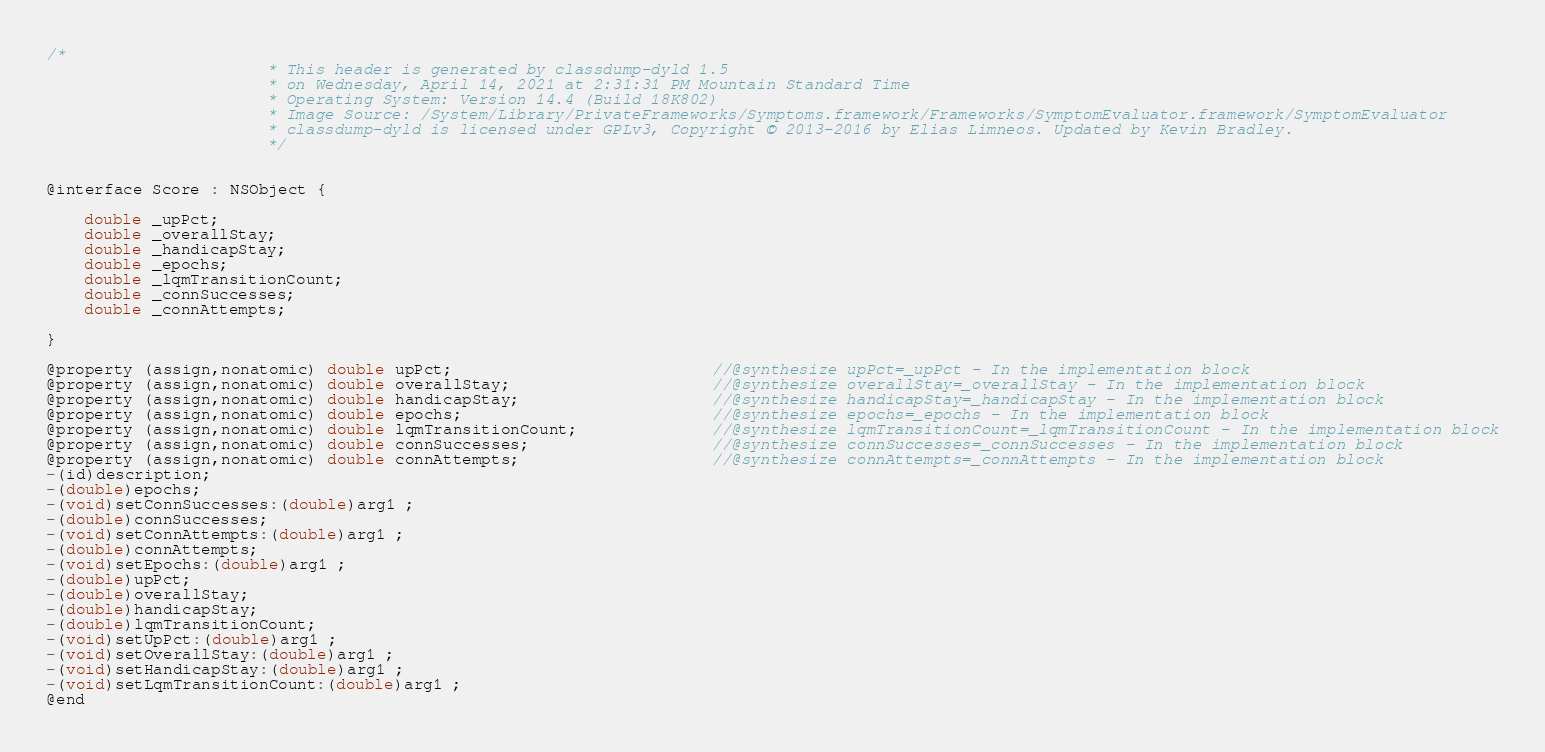Convert code to text. <code><loc_0><loc_0><loc_500><loc_500><_C_>/*
                       * This header is generated by classdump-dyld 1.5
                       * on Wednesday, April 14, 2021 at 2:31:31 PM Mountain Standard Time
                       * Operating System: Version 14.4 (Build 18K802)
                       * Image Source: /System/Library/PrivateFrameworks/Symptoms.framework/Frameworks/SymptomEvaluator.framework/SymptomEvaluator
                       * classdump-dyld is licensed under GPLv3, Copyright © 2013-2016 by Elias Limneos. Updated by Kevin Bradley.
                       */


@interface Score : NSObject {

	double _upPct;
	double _overallStay;
	double _handicapStay;
	double _epochs;
	double _lqmTransitionCount;
	double _connSuccesses;
	double _connAttempts;

}

@property (assign,nonatomic) double upPct;                           //@synthesize upPct=_upPct - In the implementation block
@property (assign,nonatomic) double overallStay;                     //@synthesize overallStay=_overallStay - In the implementation block
@property (assign,nonatomic) double handicapStay;                    //@synthesize handicapStay=_handicapStay - In the implementation block
@property (assign,nonatomic) double epochs;                          //@synthesize epochs=_epochs - In the implementation block
@property (assign,nonatomic) double lqmTransitionCount;              //@synthesize lqmTransitionCount=_lqmTransitionCount - In the implementation block
@property (assign,nonatomic) double connSuccesses;                   //@synthesize connSuccesses=_connSuccesses - In the implementation block
@property (assign,nonatomic) double connAttempts;                    //@synthesize connAttempts=_connAttempts - In the implementation block
-(id)description;
-(double)epochs;
-(void)setConnSuccesses:(double)arg1 ;
-(double)connSuccesses;
-(void)setConnAttempts:(double)arg1 ;
-(double)connAttempts;
-(void)setEpochs:(double)arg1 ;
-(double)upPct;
-(double)overallStay;
-(double)handicapStay;
-(double)lqmTransitionCount;
-(void)setUpPct:(double)arg1 ;
-(void)setOverallStay:(double)arg1 ;
-(void)setHandicapStay:(double)arg1 ;
-(void)setLqmTransitionCount:(double)arg1 ;
@end

</code> 